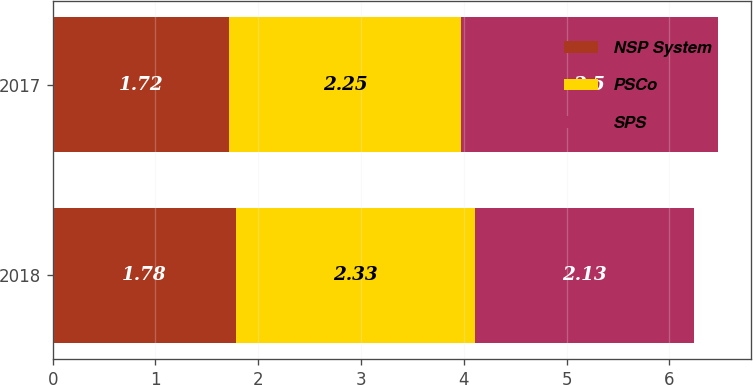Convert chart to OTSL. <chart><loc_0><loc_0><loc_500><loc_500><stacked_bar_chart><ecel><fcel>2018<fcel>2017<nl><fcel>NSP System<fcel>1.78<fcel>1.72<nl><fcel>PSCo<fcel>2.33<fcel>2.25<nl><fcel>SPS<fcel>2.13<fcel>2.5<nl></chart> 